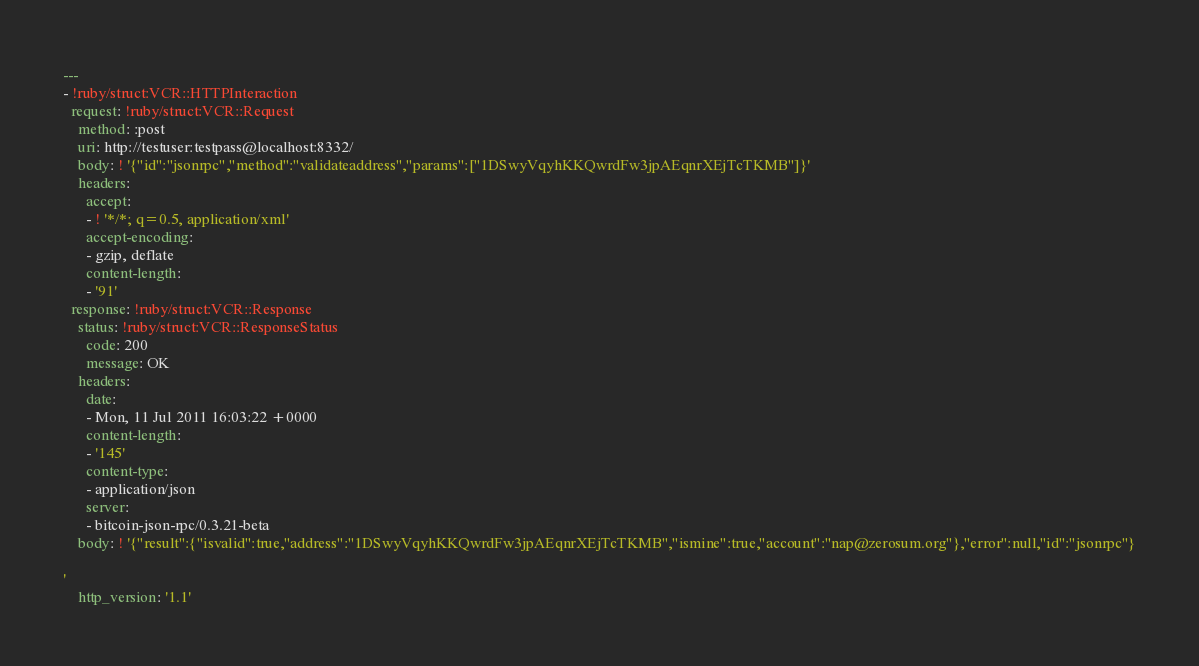<code> <loc_0><loc_0><loc_500><loc_500><_YAML_>---
- !ruby/struct:VCR::HTTPInteraction
  request: !ruby/struct:VCR::Request
    method: :post
    uri: http://testuser:testpass@localhost:8332/
    body: ! '{"id":"jsonrpc","method":"validateaddress","params":["1DSwyVqyhKKQwrdFw3jpAEqnrXEjTcTKMB"]}'
    headers:
      accept:
      - ! '*/*; q=0.5, application/xml'
      accept-encoding:
      - gzip, deflate
      content-length:
      - '91'
  response: !ruby/struct:VCR::Response
    status: !ruby/struct:VCR::ResponseStatus
      code: 200
      message: OK
    headers:
      date:
      - Mon, 11 Jul 2011 16:03:22 +0000
      content-length:
      - '145'
      content-type:
      - application/json
      server:
      - bitcoin-json-rpc/0.3.21-beta
    body: ! '{"result":{"isvalid":true,"address":"1DSwyVqyhKKQwrdFw3jpAEqnrXEjTcTKMB","ismine":true,"account":"nap@zerosum.org"},"error":null,"id":"jsonrpc"}

'
    http_version: '1.1'
</code> 